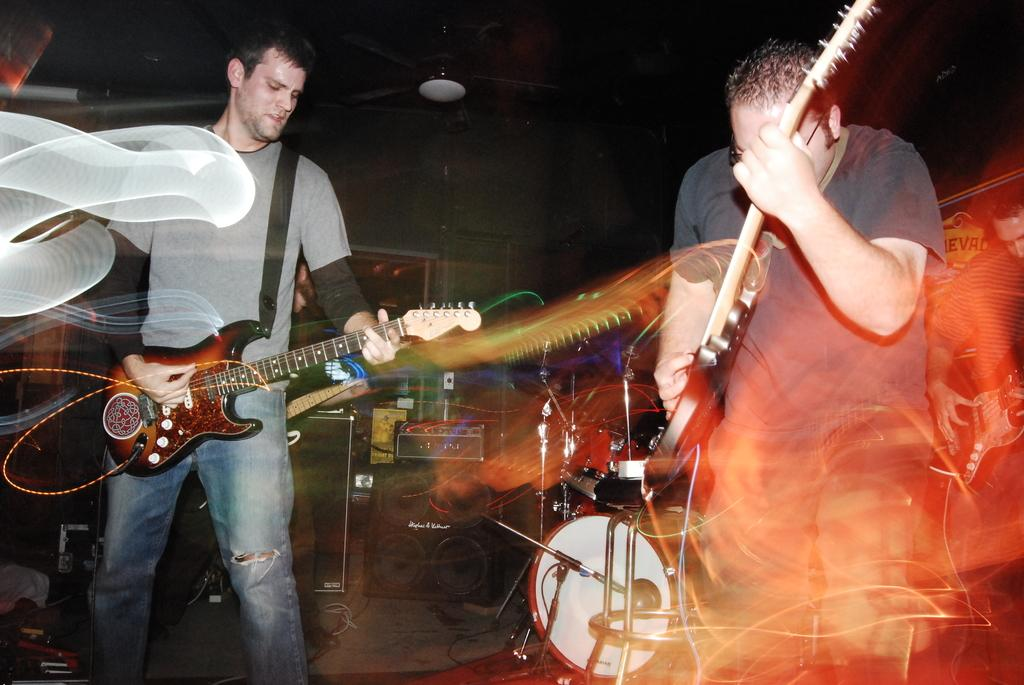How many people are in the image? There are two persons in the image. What are the two persons doing? The two persons are playing guitar. What type of surface is visible in the image? There is a floor in the image. What objects can be seen in the image related to music? There are musical instruments in the image. What can be seen in the background of the image? There is a wall and a fan in the background of the image. What type of fruit is being used as a pick to play the guitar in the image? There is no fruit being used as a pick to play the guitar in the image. How does the spark from the fan affect the guitar playing in the image? There is no spark from the fan in the image, and it does not affect the guitar playing. 